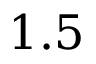Convert formula to latex. <formula><loc_0><loc_0><loc_500><loc_500>1 . 5</formula> 